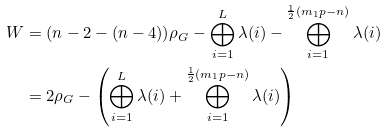<formula> <loc_0><loc_0><loc_500><loc_500>W & = ( n - 2 - ( n - 4 ) ) \rho _ { G } - \bigoplus _ { i = 1 } ^ { L } \lambda ( i ) - \bigoplus _ { i = 1 } ^ { \frac { 1 } { 2 } ( m _ { 1 } p - n ) } \lambda ( i ) \\ & = 2 \rho _ { G } - \left ( \bigoplus _ { i = 1 } ^ { L } \lambda ( i ) + \bigoplus _ { i = 1 } ^ { \frac { 1 } { 2 } ( m _ { 1 } p - n ) } \lambda ( i ) \right )</formula> 